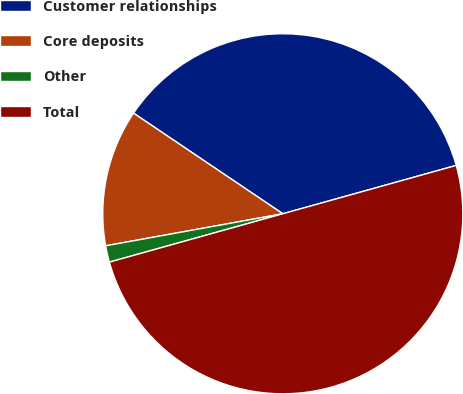<chart> <loc_0><loc_0><loc_500><loc_500><pie_chart><fcel>Customer relationships<fcel>Core deposits<fcel>Other<fcel>Total<nl><fcel>36.23%<fcel>12.29%<fcel>1.48%<fcel>50.0%<nl></chart> 